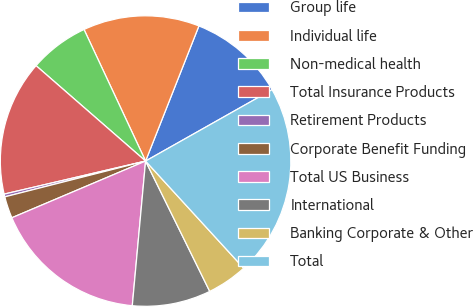Convert chart. <chart><loc_0><loc_0><loc_500><loc_500><pie_chart><fcel>Group life<fcel>Individual life<fcel>Non-medical health<fcel>Total Insurance Products<fcel>Retirement Products<fcel>Corporate Benefit Funding<fcel>Total US Business<fcel>International<fcel>Banking Corporate & Other<fcel>Total<nl><fcel>10.84%<fcel>12.95%<fcel>6.63%<fcel>15.06%<fcel>0.31%<fcel>2.42%<fcel>17.16%<fcel>8.74%<fcel>4.52%<fcel>21.38%<nl></chart> 